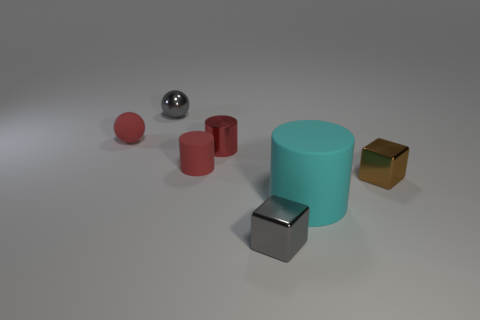What is the material of the small cube that is the same color as the metal sphere?
Your answer should be very brief. Metal. Is there anything else that has the same size as the cyan matte cylinder?
Your response must be concise. No. There is a metal object that is in front of the small brown block; does it have the same color as the ball behind the matte sphere?
Provide a succinct answer. Yes. There is another tiny metallic thing that is the same shape as the brown metallic object; what color is it?
Offer a terse response. Gray. The tiny red thing that is both behind the tiny matte cylinder and on the right side of the small rubber sphere is made of what material?
Offer a very short reply. Metal. Is the material of the small red sphere the same as the large cyan object?
Provide a succinct answer. Yes. What number of tiny gray matte things are there?
Offer a very short reply. 0. There is a shiny block that is left of the big cyan cylinder that is to the right of the small block in front of the large cyan rubber thing; what is its color?
Keep it short and to the point. Gray. Does the big object have the same color as the small rubber ball?
Give a very brief answer. No. How many things are both right of the tiny matte cylinder and behind the cyan matte thing?
Provide a succinct answer. 2. 